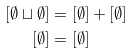<formula> <loc_0><loc_0><loc_500><loc_500>[ \emptyset \sqcup \emptyset ] & = [ \emptyset ] + [ \emptyset ] \\ [ \emptyset ] & = [ \emptyset ]</formula> 